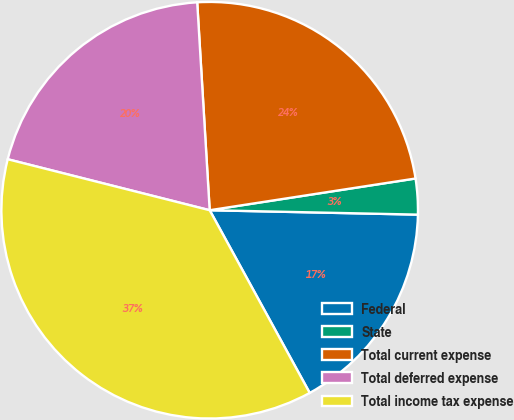Convert chart. <chart><loc_0><loc_0><loc_500><loc_500><pie_chart><fcel>Federal<fcel>State<fcel>Total current expense<fcel>Total deferred expense<fcel>Total income tax expense<nl><fcel>16.69%<fcel>2.77%<fcel>23.52%<fcel>20.11%<fcel>36.91%<nl></chart> 